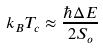<formula> <loc_0><loc_0><loc_500><loc_500>k _ { B } T _ { c } \approx \frac { \hbar { \Delta } E } { 2 S _ { o } }</formula> 